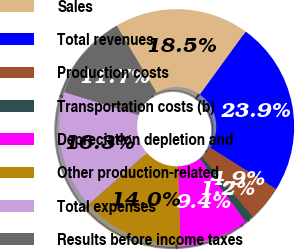<chart> <loc_0><loc_0><loc_500><loc_500><pie_chart><fcel>Sales<fcel>Total revenues<fcel>Production costs<fcel>Transportation costs (b)<fcel>Depreciation depletion and<fcel>Other production-related<fcel>Total expenses<fcel>Results before income taxes<nl><fcel>18.54%<fcel>23.93%<fcel>4.9%<fcel>1.2%<fcel>9.45%<fcel>13.99%<fcel>16.27%<fcel>11.72%<nl></chart> 